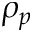Convert formula to latex. <formula><loc_0><loc_0><loc_500><loc_500>\rho _ { p }</formula> 